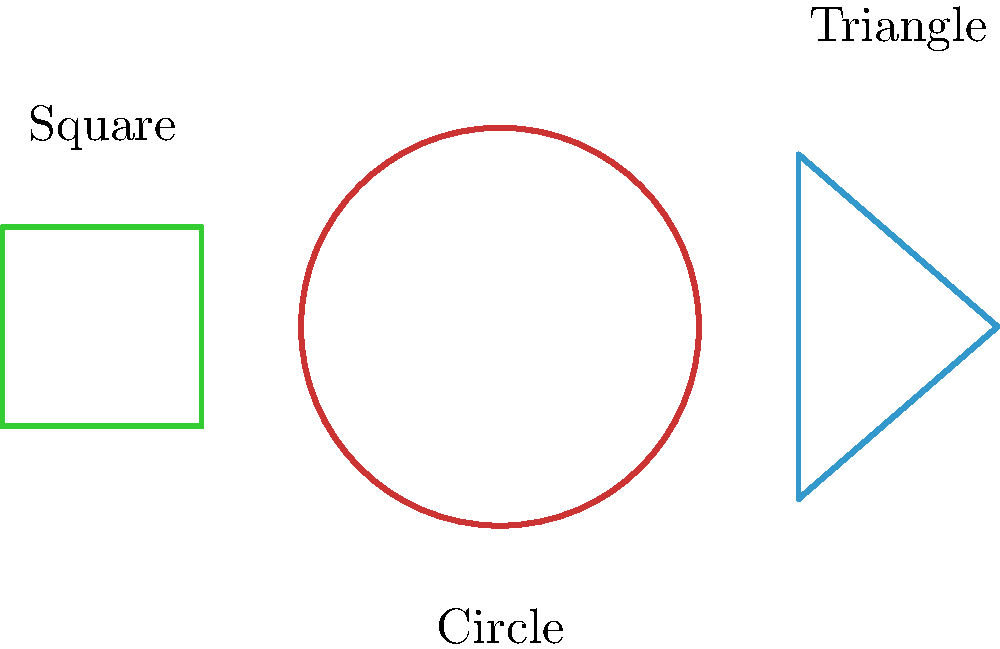In minimalist design, which of the geometric shapes depicted above is most likely to evoke a sense of completeness and harmony, aligning with the emotional resonance often sought in poetic expression? To answer this question, we need to consider the emotional and symbolic associations of each shape in the context of minimalist design and poetic expression:

1. Circle:
   - Represents wholeness, unity, and infinity
   - No beginning or end, suggesting continuity and cyclical nature
   - Soft, flowing form without sharp edges
   - Often associated with natural forms (e.g., sun, moon)

2. Triangle:
   - Symbolizes stability, but also tension and dynamic energy
   - Sharp angles can create a sense of direction or movement
   - Often associated with masculine energy or hierarchical structures

3. Square:
   - Represents stability, balance, and solidity
   - Equal sides suggest fairness and rationality
   - Can feel rigid or constrained compared to organic shapes

In the context of poetic expression and emotional resonance:

- The circle's continuous form and associations with natural cycles align well with the flowing nature of poetry and emotional expression.
- Its lack of sharp edges or corners creates a sense of harmony and completeness.
- The circle's symbolism of unity and wholeness resonates with the idea of encompassing complex emotions in a single, cohesive form.

While all shapes can be used effectively in minimalist design, the circle's properties make it particularly well-suited for evoking the emotional resonance often sought in poetic expression.
Answer: Circle 